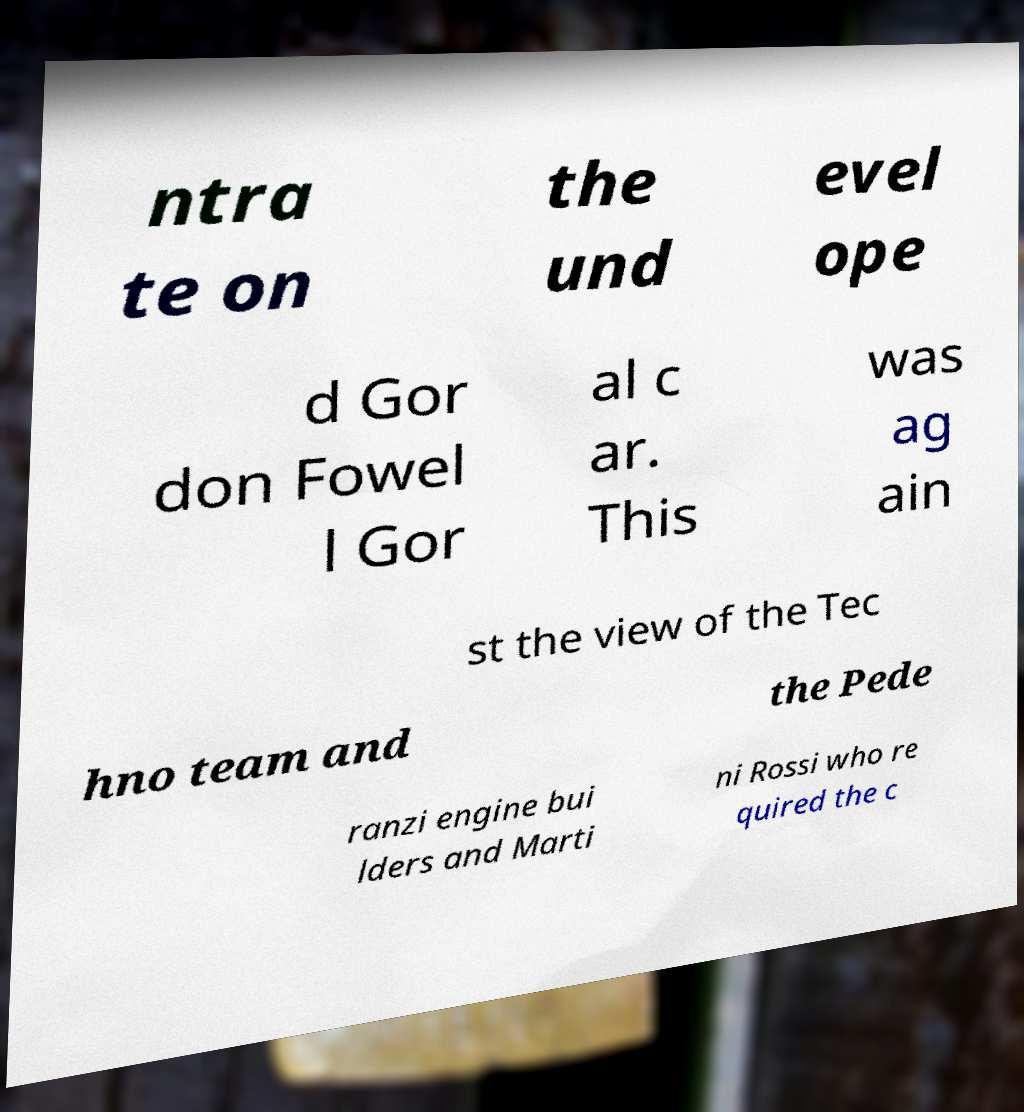Can you accurately transcribe the text from the provided image for me? ntra te on the und evel ope d Gor don Fowel l Gor al c ar. This was ag ain st the view of the Tec hno team and the Pede ranzi engine bui lders and Marti ni Rossi who re quired the c 